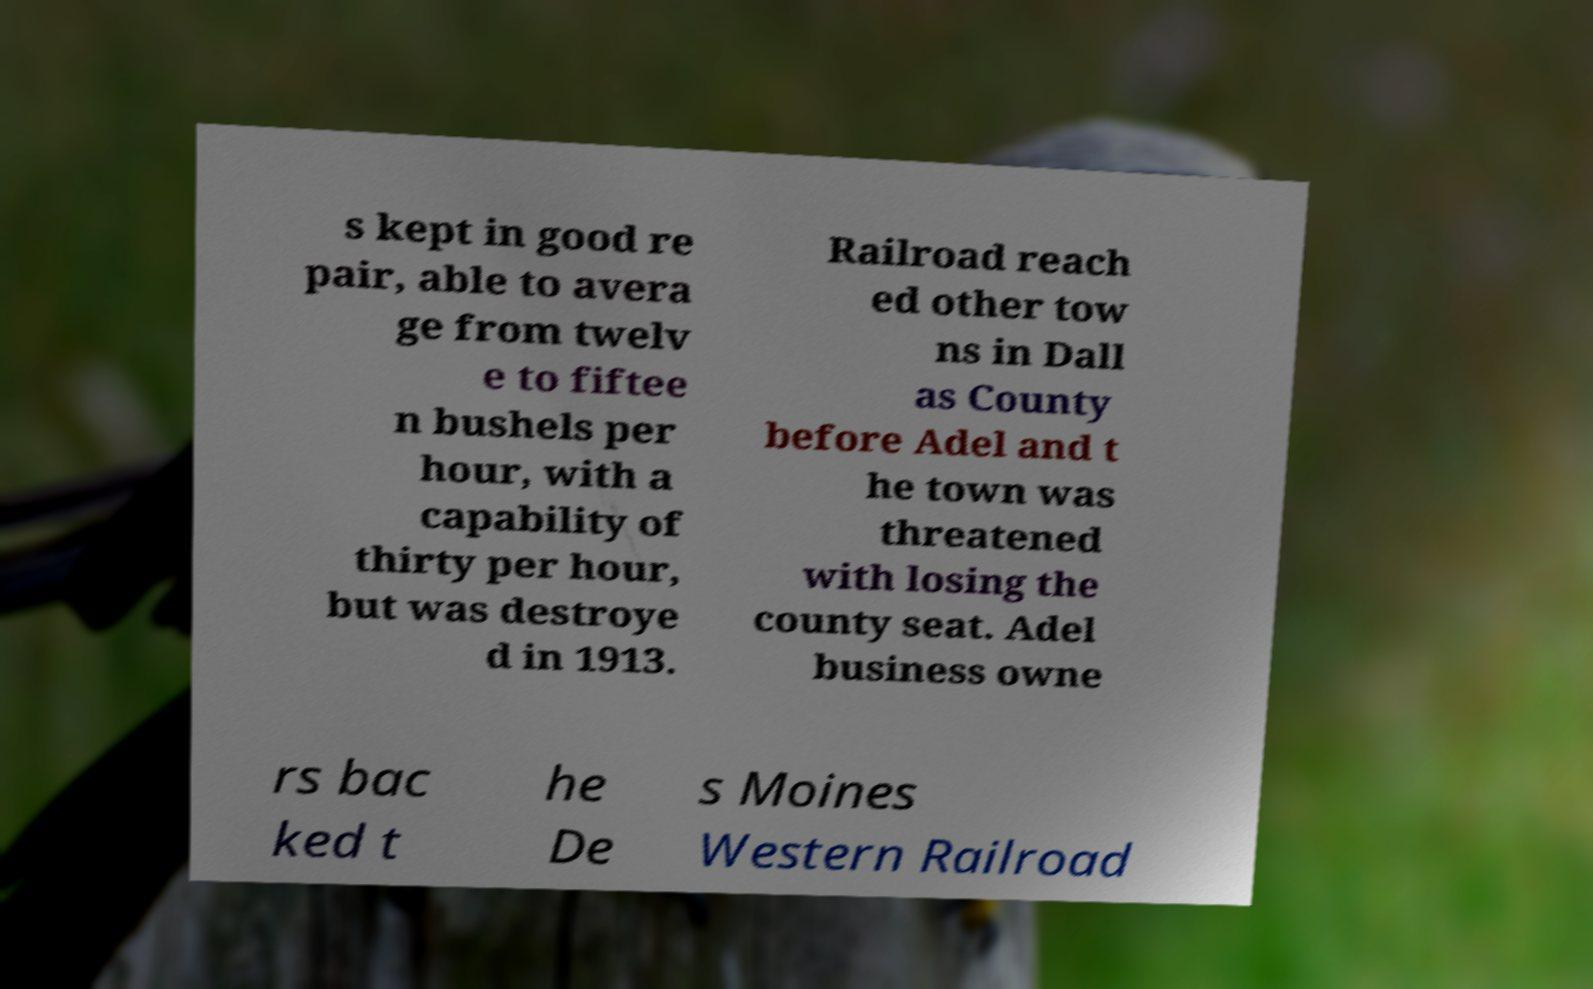Please identify and transcribe the text found in this image. s kept in good re pair, able to avera ge from twelv e to fiftee n bushels per hour, with a capability of thirty per hour, but was destroye d in 1913. Railroad reach ed other tow ns in Dall as County before Adel and t he town was threatened with losing the county seat. Adel business owne rs bac ked t he De s Moines Western Railroad 